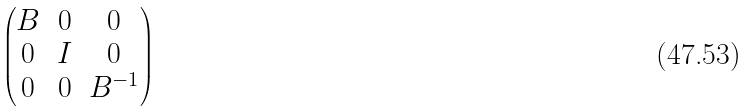<formula> <loc_0><loc_0><loc_500><loc_500>\begin{pmatrix} B & 0 & 0 \\ 0 & I & 0 \\ 0 & 0 & B ^ { - 1 } \end{pmatrix}</formula> 